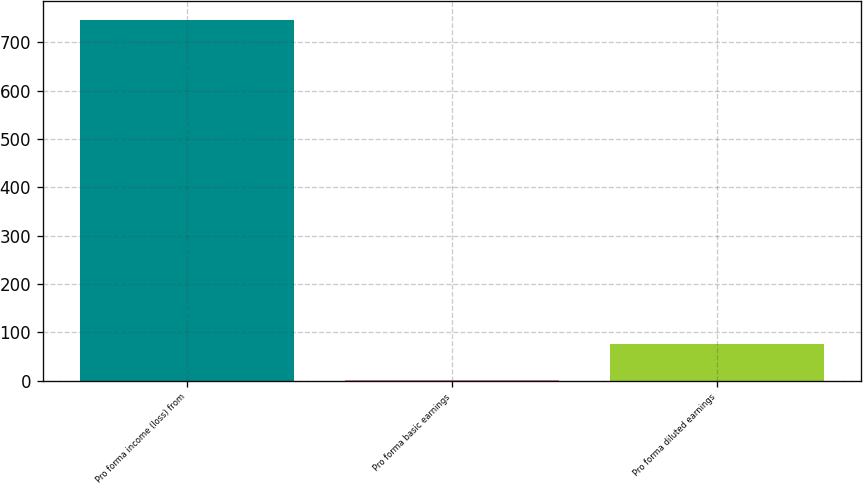Convert chart to OTSL. <chart><loc_0><loc_0><loc_500><loc_500><bar_chart><fcel>Pro forma income (loss) from<fcel>Pro forma basic earnings<fcel>Pro forma diluted earnings<nl><fcel>746.9<fcel>1.26<fcel>75.82<nl></chart> 